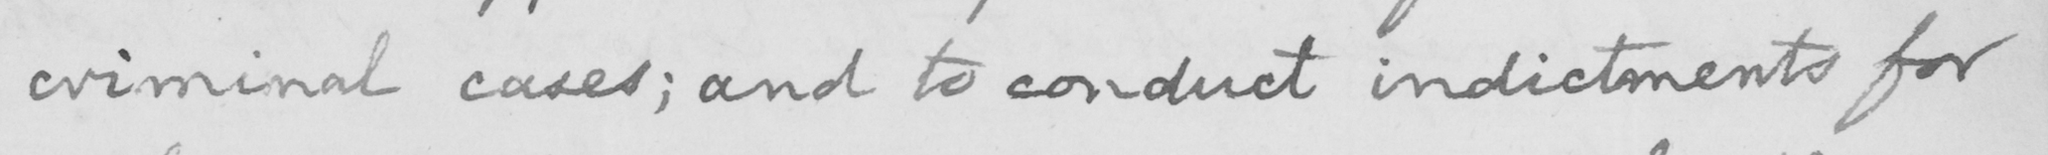Please transcribe the handwritten text in this image. criminal cases; and to conduct indictments for 